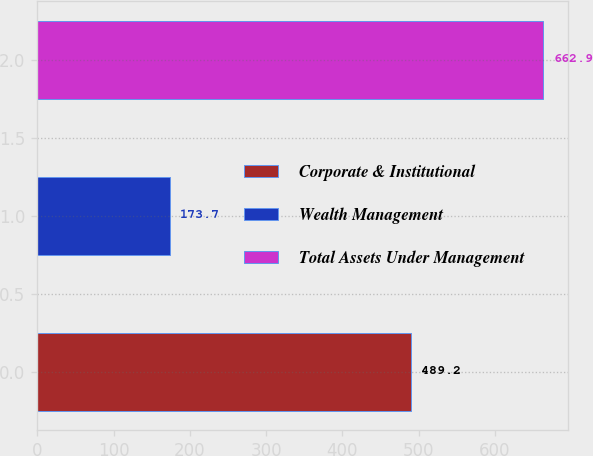<chart> <loc_0><loc_0><loc_500><loc_500><bar_chart><fcel>Corporate & Institutional<fcel>Wealth Management<fcel>Total Assets Under Management<nl><fcel>489.2<fcel>173.7<fcel>662.9<nl></chart> 